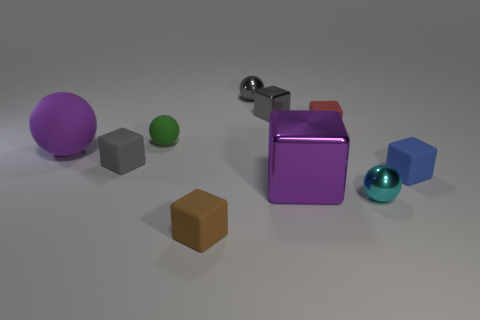How big is the shiny cube that is behind the tiny green matte object that is on the left side of the small gray metal object in front of the small gray sphere?
Your answer should be compact. Small. How many objects are either balls in front of the green matte sphere or small matte objects behind the green matte sphere?
Your answer should be very brief. 3. What is the shape of the cyan shiny thing?
Your response must be concise. Sphere. What number of other things are there of the same material as the gray ball
Ensure brevity in your answer.  3. What is the size of the purple object that is the same shape as the tiny brown thing?
Provide a succinct answer. Large. There is a gray cube on the left side of the shiny ball that is behind the small gray cube that is in front of the tiny green object; what is it made of?
Offer a terse response. Rubber. Is there a small brown thing?
Ensure brevity in your answer.  Yes. Does the big block have the same color as the big thing that is on the left side of the brown cube?
Your answer should be very brief. Yes. What color is the large shiny cube?
Provide a short and direct response. Purple. The small metallic object that is the same shape as the red matte thing is what color?
Offer a terse response. Gray. 